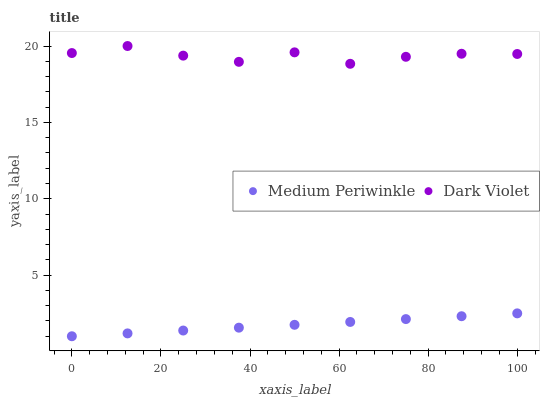Does Medium Periwinkle have the minimum area under the curve?
Answer yes or no. Yes. Does Dark Violet have the maximum area under the curve?
Answer yes or no. Yes. Does Dark Violet have the minimum area under the curve?
Answer yes or no. No. Is Medium Periwinkle the smoothest?
Answer yes or no. Yes. Is Dark Violet the roughest?
Answer yes or no. Yes. Is Dark Violet the smoothest?
Answer yes or no. No. Does Medium Periwinkle have the lowest value?
Answer yes or no. Yes. Does Dark Violet have the lowest value?
Answer yes or no. No. Does Dark Violet have the highest value?
Answer yes or no. Yes. Is Medium Periwinkle less than Dark Violet?
Answer yes or no. Yes. Is Dark Violet greater than Medium Periwinkle?
Answer yes or no. Yes. Does Medium Periwinkle intersect Dark Violet?
Answer yes or no. No. 